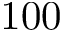Convert formula to latex. <formula><loc_0><loc_0><loc_500><loc_500>1 0 0</formula> 